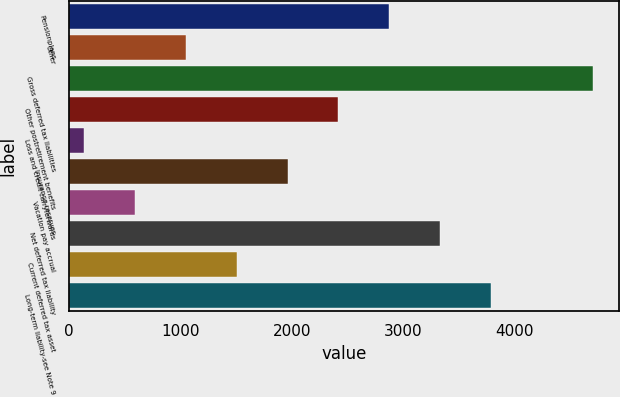Convert chart. <chart><loc_0><loc_0><loc_500><loc_500><bar_chart><fcel>Pensionplans<fcel>Other<fcel>Gross deferred tax liabilities<fcel>Other postretirement benefits<fcel>Loss and credit carryforwards<fcel>Insurance reserves<fcel>Vacation pay accrual<fcel>Net deferred tax liability<fcel>Current deferred tax asset<fcel>Long-term liability-see Note 9<nl><fcel>2874<fcel>1048<fcel>4700<fcel>2417.5<fcel>135<fcel>1961<fcel>591.5<fcel>3330.5<fcel>1504.5<fcel>3787<nl></chart> 